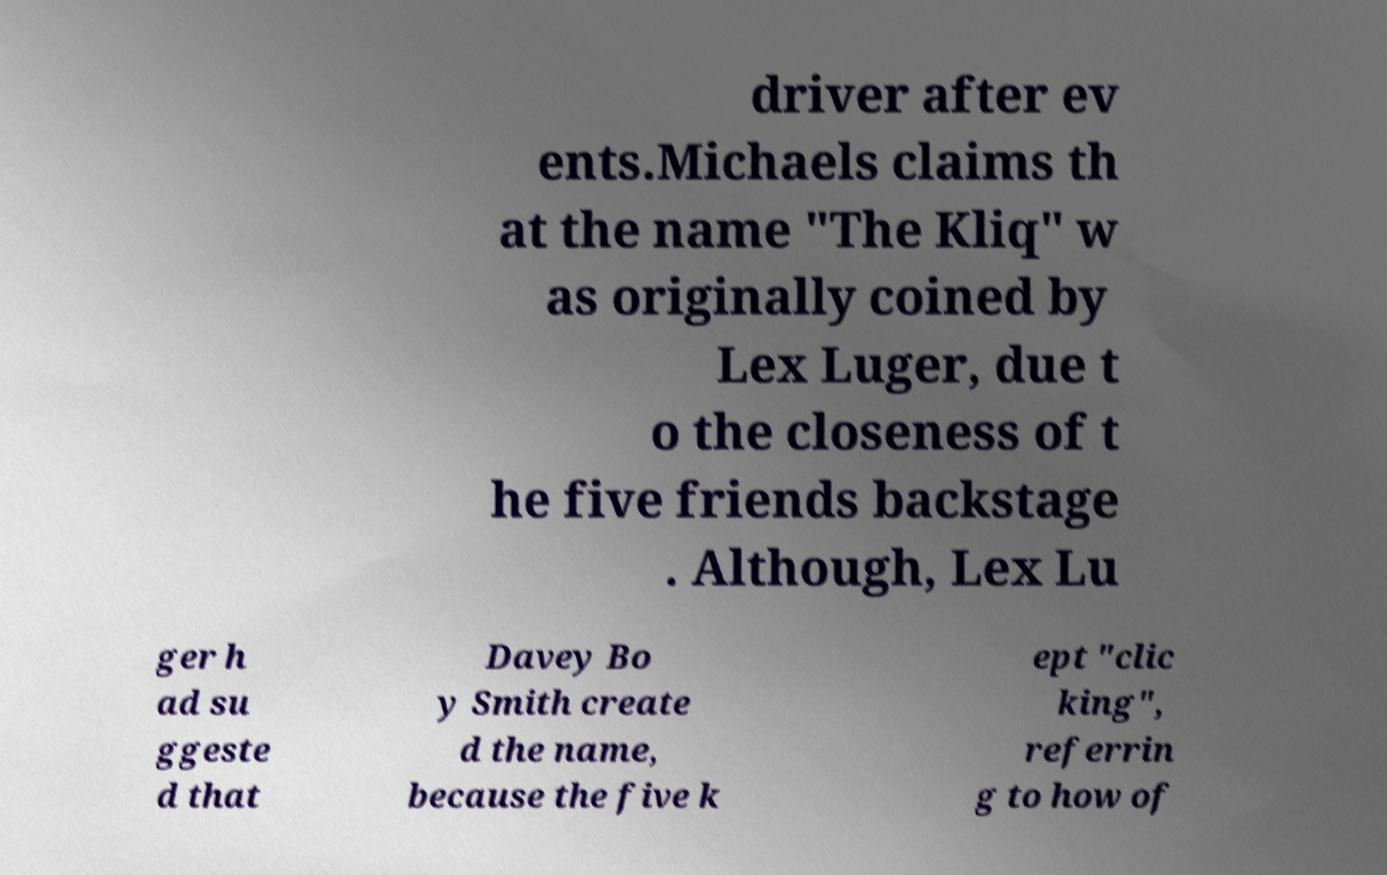What messages or text are displayed in this image? I need them in a readable, typed format. driver after ev ents.Michaels claims th at the name "The Kliq" w as originally coined by Lex Luger, due t o the closeness of t he five friends backstage . Although, Lex Lu ger h ad su ggeste d that Davey Bo y Smith create d the name, because the five k ept "clic king", referrin g to how of 